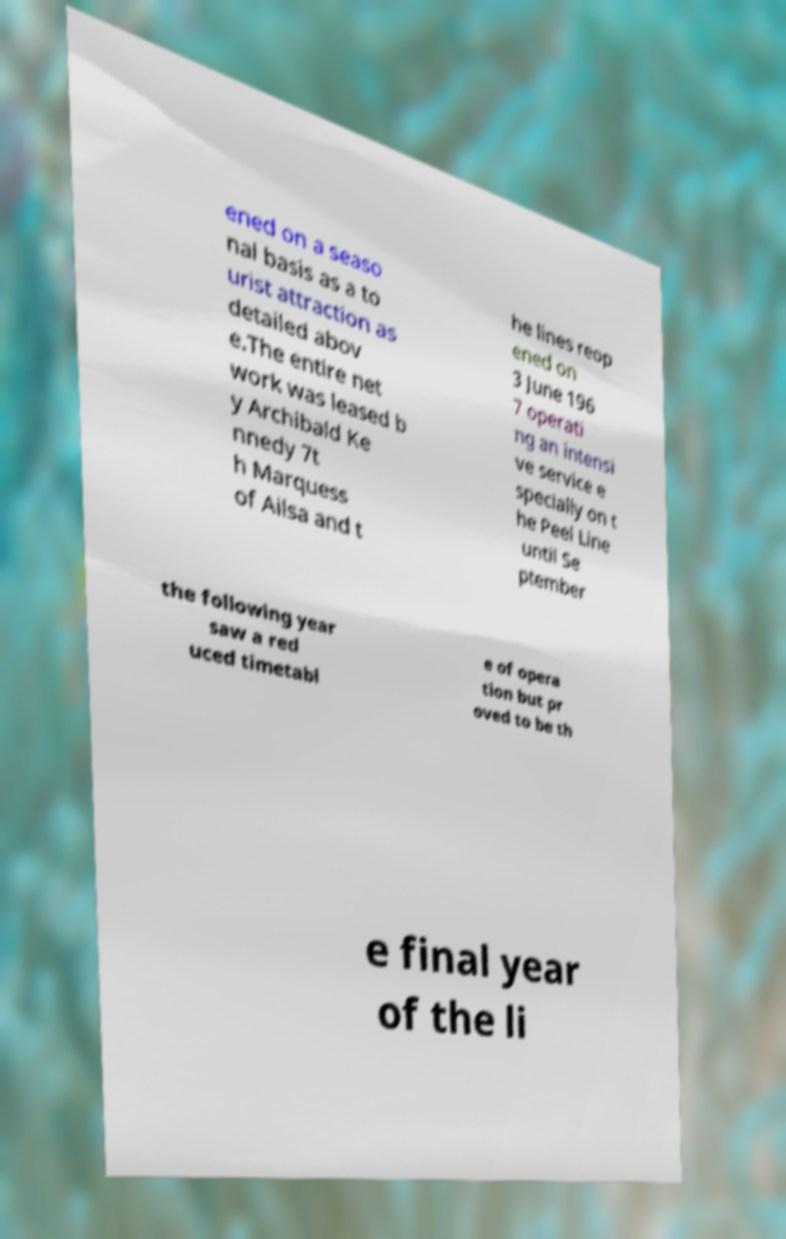Could you assist in decoding the text presented in this image and type it out clearly? ened on a seaso nal basis as a to urist attraction as detailed abov e.The entire net work was leased b y Archibald Ke nnedy 7t h Marquess of Ailsa and t he lines reop ened on 3 June 196 7 operati ng an intensi ve service e specially on t he Peel Line until Se ptember the following year saw a red uced timetabl e of opera tion but pr oved to be th e final year of the li 